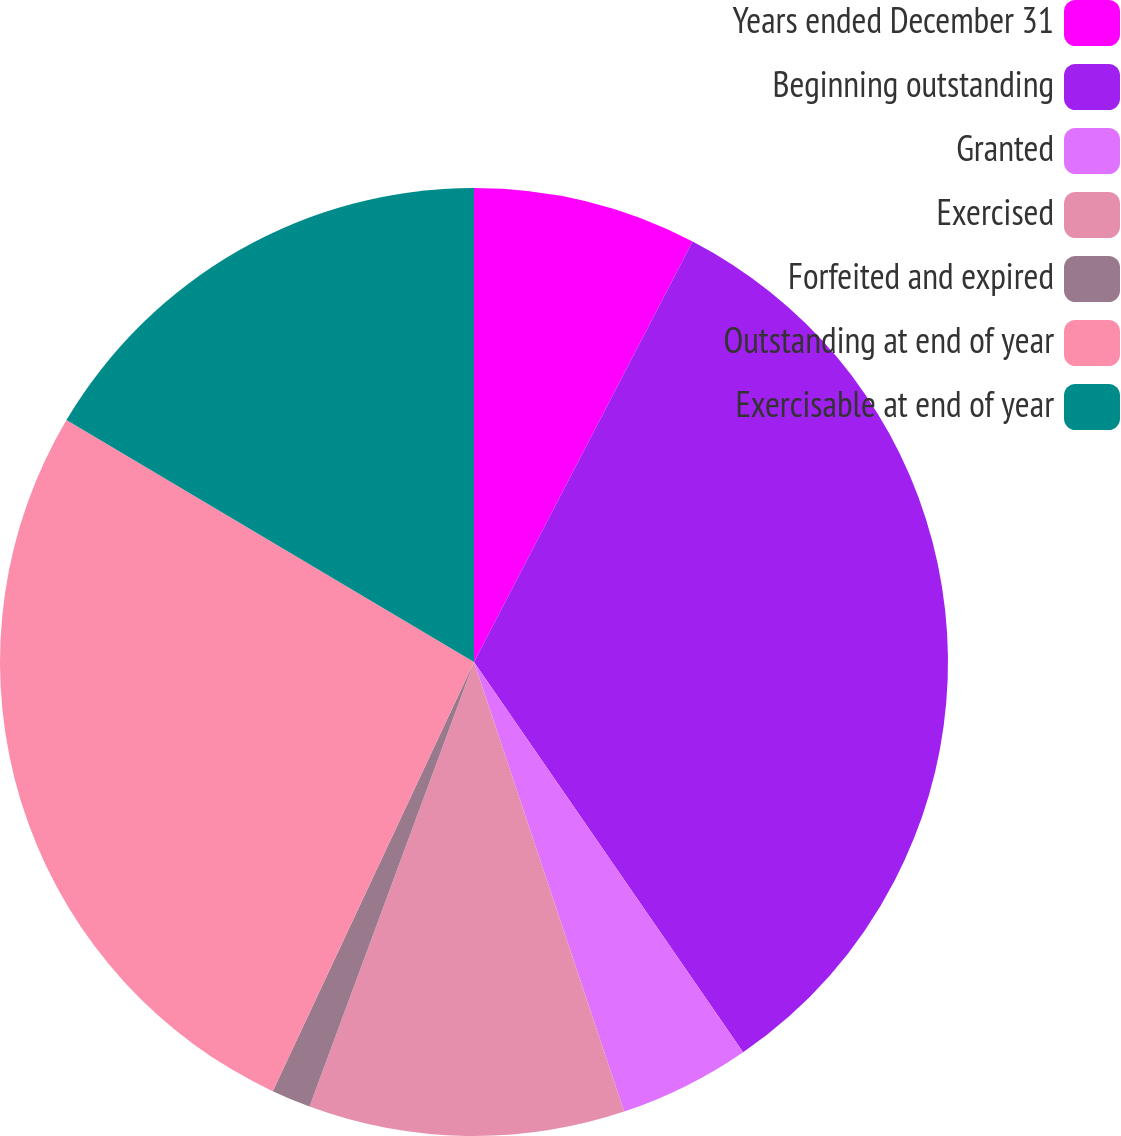Convert chart to OTSL. <chart><loc_0><loc_0><loc_500><loc_500><pie_chart><fcel>Years ended December 31<fcel>Beginning outstanding<fcel>Granted<fcel>Exercised<fcel>Forfeited and expired<fcel>Outstanding at end of year<fcel>Exercisable at end of year<nl><fcel>7.63%<fcel>32.76%<fcel>4.48%<fcel>10.77%<fcel>1.34%<fcel>26.55%<fcel>16.47%<nl></chart> 